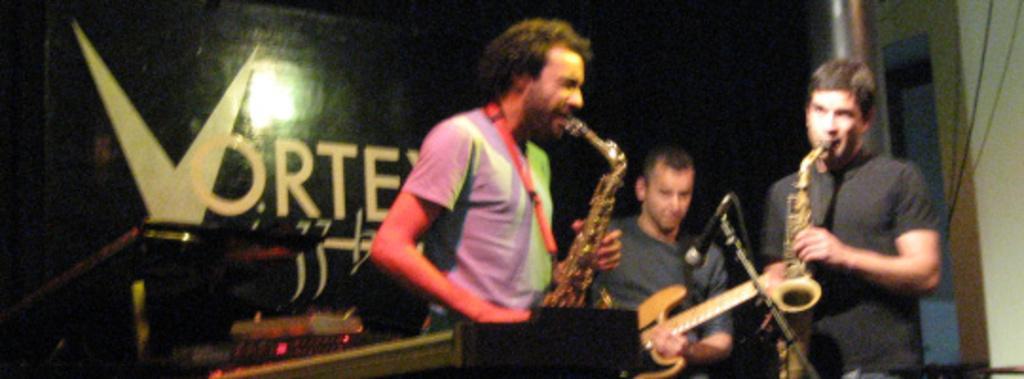Describe this image in one or two sentences. This is a blurred picture where we can see three people playing some musical instruments and two among them are in black tee shirts. 